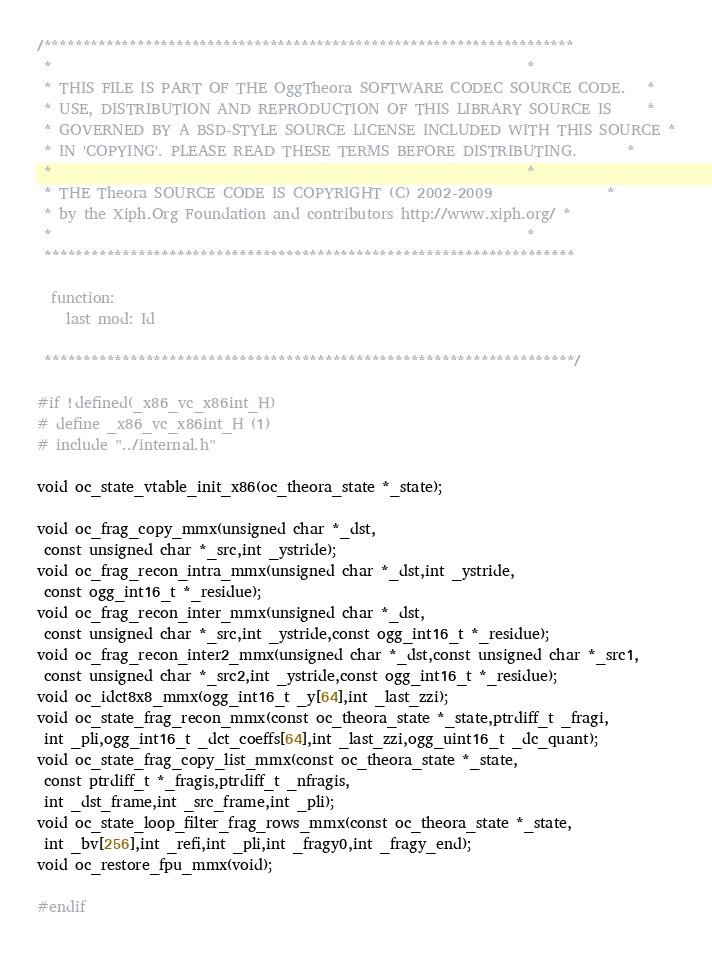Convert code to text. <code><loc_0><loc_0><loc_500><loc_500><_C_>/********************************************************************
 *                                                                  *
 * THIS FILE IS PART OF THE OggTheora SOFTWARE CODEC SOURCE CODE.   *
 * USE, DISTRIBUTION AND REPRODUCTION OF THIS LIBRARY SOURCE IS     *
 * GOVERNED BY A BSD-STYLE SOURCE LICENSE INCLUDED WITH THIS SOURCE *
 * IN 'COPYING'. PLEASE READ THESE TERMS BEFORE DISTRIBUTING.       *
 *                                                                  *
 * THE Theora SOURCE CODE IS COPYRIGHT (C) 2002-2009                *
 * by the Xiph.Org Foundation and contributors http://www.xiph.org/ *
 *                                                                  *
 ********************************************************************

  function:
    last mod: Id

 ********************************************************************/

#if !defined(_x86_vc_x86int_H)
# define _x86_vc_x86int_H (1)
# include "../internal.h"

void oc_state_vtable_init_x86(oc_theora_state *_state);

void oc_frag_copy_mmx(unsigned char *_dst,
 const unsigned char *_src,int _ystride);
void oc_frag_recon_intra_mmx(unsigned char *_dst,int _ystride,
 const ogg_int16_t *_residue);
void oc_frag_recon_inter_mmx(unsigned char *_dst,
 const unsigned char *_src,int _ystride,const ogg_int16_t *_residue);
void oc_frag_recon_inter2_mmx(unsigned char *_dst,const unsigned char *_src1,
 const unsigned char *_src2,int _ystride,const ogg_int16_t *_residue);
void oc_idct8x8_mmx(ogg_int16_t _y[64],int _last_zzi);
void oc_state_frag_recon_mmx(const oc_theora_state *_state,ptrdiff_t _fragi,
 int _pli,ogg_int16_t _dct_coeffs[64],int _last_zzi,ogg_uint16_t _dc_quant);
void oc_state_frag_copy_list_mmx(const oc_theora_state *_state,
 const ptrdiff_t *_fragis,ptrdiff_t _nfragis,
 int _dst_frame,int _src_frame,int _pli);
void oc_state_loop_filter_frag_rows_mmx(const oc_theora_state *_state,
 int _bv[256],int _refi,int _pli,int _fragy0,int _fragy_end);
void oc_restore_fpu_mmx(void);

#endif
</code> 